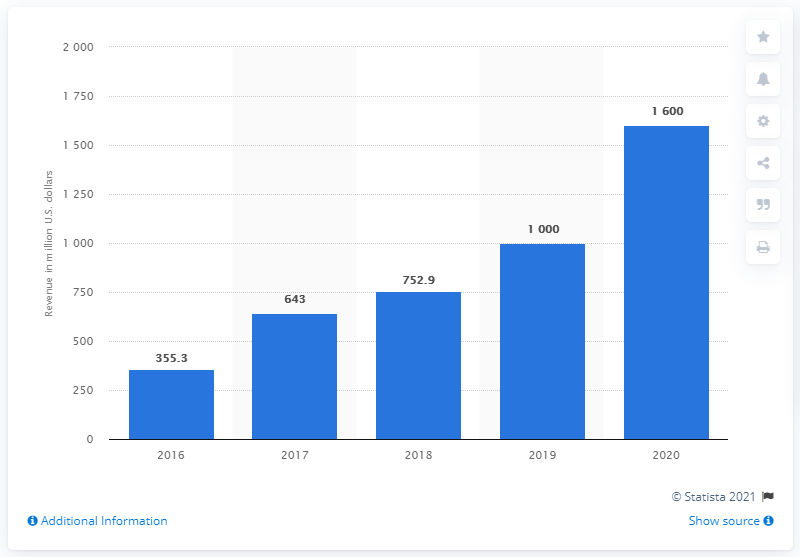What was Snapchat's social networking revenue in the United States in 2020?
 1600 